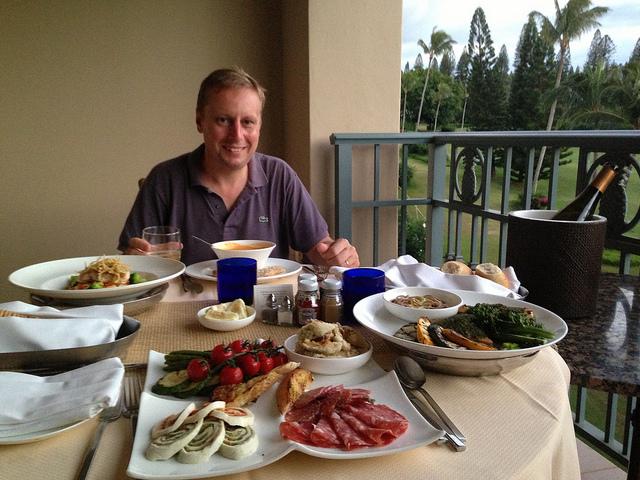Is this on a patio?
Answer briefly. Yes. Are the bowls antiques?
Concise answer only. No. Did he order a lot of food?
Write a very short answer. Yes. Does this picture look like it came from an old cookbook?
Concise answer only. No. Is this picture seems to be in a restaurant?
Quick response, please. No. Is he ready to eat?
Give a very brief answer. Yes. How many people are shown at the table?
Write a very short answer. 1. 